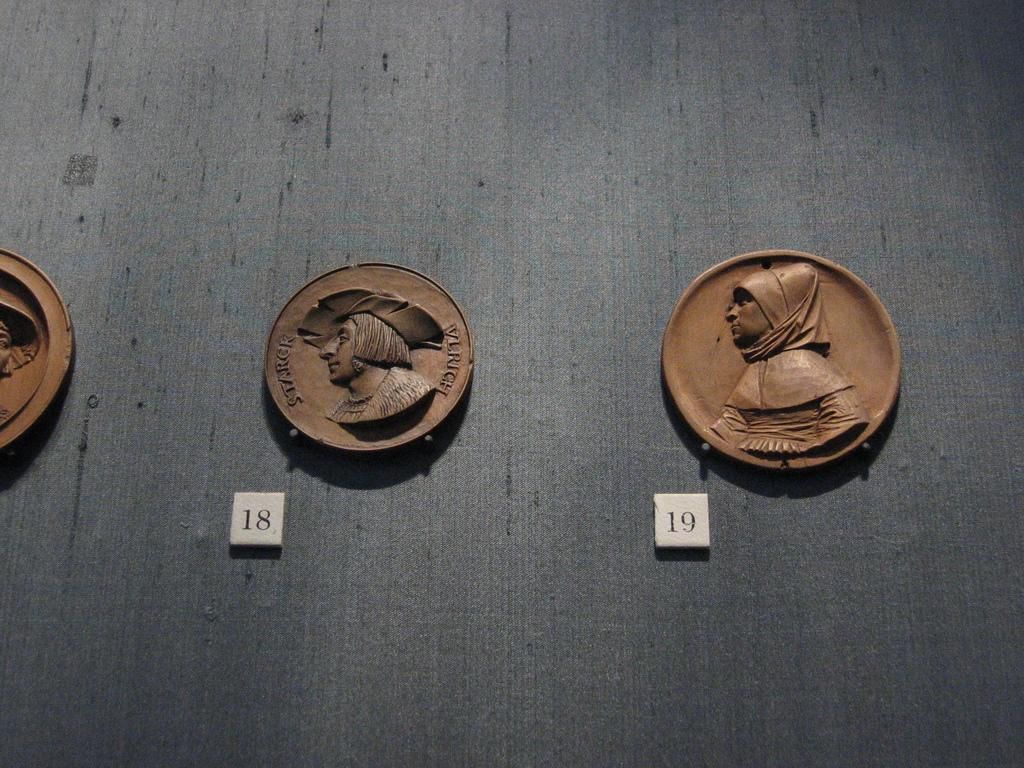<image>
Summarize the visual content of the image. Several coins, two labeled with the numbers 18 and 19, 18 has Starck stamped in it. 